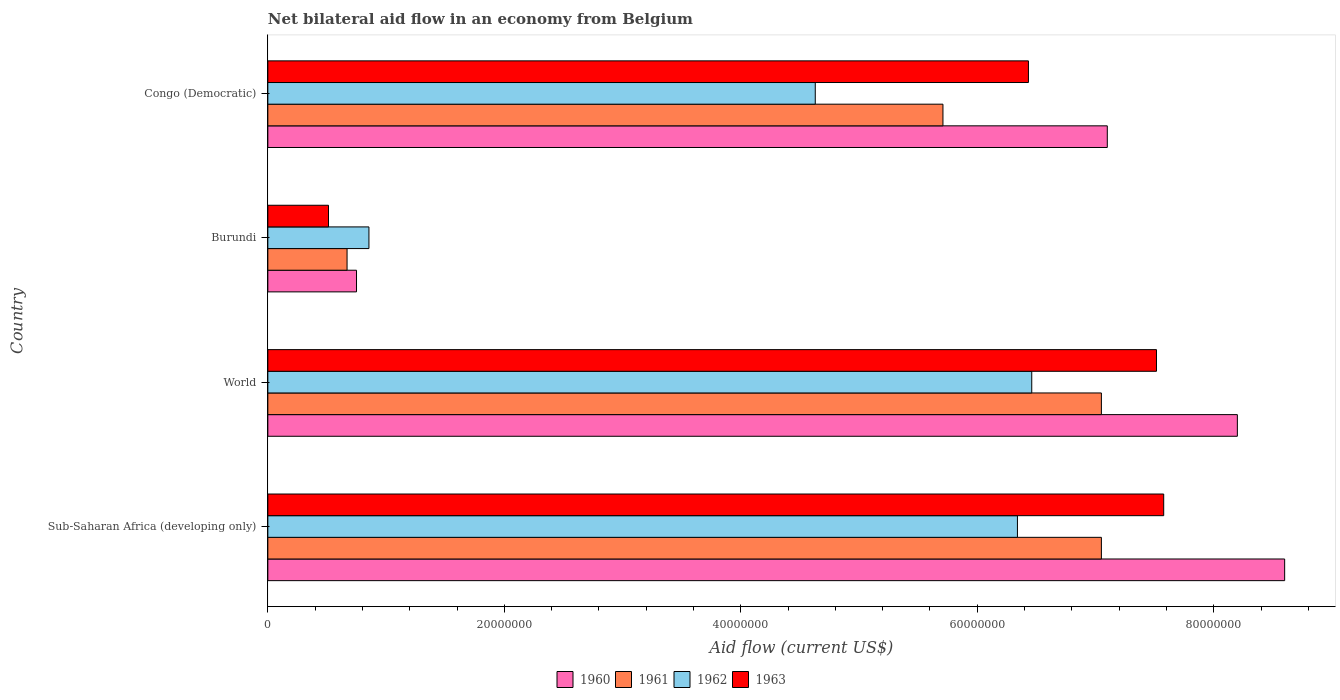How many different coloured bars are there?
Give a very brief answer. 4. How many groups of bars are there?
Provide a short and direct response. 4. Are the number of bars per tick equal to the number of legend labels?
Your answer should be compact. Yes. What is the label of the 4th group of bars from the top?
Offer a very short reply. Sub-Saharan Africa (developing only). In how many cases, is the number of bars for a given country not equal to the number of legend labels?
Give a very brief answer. 0. What is the net bilateral aid flow in 1960 in Sub-Saharan Africa (developing only)?
Keep it short and to the point. 8.60e+07. Across all countries, what is the maximum net bilateral aid flow in 1960?
Offer a terse response. 8.60e+07. Across all countries, what is the minimum net bilateral aid flow in 1962?
Offer a terse response. 8.55e+06. In which country was the net bilateral aid flow in 1960 maximum?
Give a very brief answer. Sub-Saharan Africa (developing only). In which country was the net bilateral aid flow in 1962 minimum?
Make the answer very short. Burundi. What is the total net bilateral aid flow in 1962 in the graph?
Ensure brevity in your answer.  1.83e+08. What is the difference between the net bilateral aid flow in 1963 in Burundi and that in Sub-Saharan Africa (developing only)?
Your answer should be very brief. -7.06e+07. What is the difference between the net bilateral aid flow in 1963 in Burundi and the net bilateral aid flow in 1962 in World?
Offer a very short reply. -5.95e+07. What is the average net bilateral aid flow in 1960 per country?
Keep it short and to the point. 6.16e+07. What is the difference between the net bilateral aid flow in 1961 and net bilateral aid flow in 1960 in Burundi?
Give a very brief answer. -8.00e+05. In how many countries, is the net bilateral aid flow in 1962 greater than 12000000 US$?
Your response must be concise. 3. What is the ratio of the net bilateral aid flow in 1960 in Burundi to that in Sub-Saharan Africa (developing only)?
Your answer should be very brief. 0.09. Is the net bilateral aid flow in 1962 in Burundi less than that in Congo (Democratic)?
Ensure brevity in your answer.  Yes. What is the difference between the highest and the second highest net bilateral aid flow in 1960?
Make the answer very short. 4.00e+06. What is the difference between the highest and the lowest net bilateral aid flow in 1960?
Your response must be concise. 7.85e+07. In how many countries, is the net bilateral aid flow in 1961 greater than the average net bilateral aid flow in 1961 taken over all countries?
Provide a short and direct response. 3. Is it the case that in every country, the sum of the net bilateral aid flow in 1960 and net bilateral aid flow in 1963 is greater than the sum of net bilateral aid flow in 1962 and net bilateral aid flow in 1961?
Provide a short and direct response. No. Is it the case that in every country, the sum of the net bilateral aid flow in 1963 and net bilateral aid flow in 1961 is greater than the net bilateral aid flow in 1960?
Offer a very short reply. Yes. How many bars are there?
Provide a succinct answer. 16. Are all the bars in the graph horizontal?
Provide a short and direct response. Yes. What is the difference between two consecutive major ticks on the X-axis?
Give a very brief answer. 2.00e+07. Are the values on the major ticks of X-axis written in scientific E-notation?
Your response must be concise. No. Does the graph contain any zero values?
Offer a very short reply. No. Does the graph contain grids?
Offer a terse response. No. How many legend labels are there?
Offer a terse response. 4. How are the legend labels stacked?
Offer a terse response. Horizontal. What is the title of the graph?
Keep it short and to the point. Net bilateral aid flow in an economy from Belgium. Does "2014" appear as one of the legend labels in the graph?
Your response must be concise. No. What is the Aid flow (current US$) of 1960 in Sub-Saharan Africa (developing only)?
Your response must be concise. 8.60e+07. What is the Aid flow (current US$) of 1961 in Sub-Saharan Africa (developing only)?
Provide a short and direct response. 7.05e+07. What is the Aid flow (current US$) in 1962 in Sub-Saharan Africa (developing only)?
Provide a short and direct response. 6.34e+07. What is the Aid flow (current US$) in 1963 in Sub-Saharan Africa (developing only)?
Your response must be concise. 7.58e+07. What is the Aid flow (current US$) in 1960 in World?
Give a very brief answer. 8.20e+07. What is the Aid flow (current US$) in 1961 in World?
Offer a very short reply. 7.05e+07. What is the Aid flow (current US$) in 1962 in World?
Offer a very short reply. 6.46e+07. What is the Aid flow (current US$) in 1963 in World?
Provide a succinct answer. 7.52e+07. What is the Aid flow (current US$) of 1960 in Burundi?
Provide a short and direct response. 7.50e+06. What is the Aid flow (current US$) in 1961 in Burundi?
Provide a succinct answer. 6.70e+06. What is the Aid flow (current US$) of 1962 in Burundi?
Ensure brevity in your answer.  8.55e+06. What is the Aid flow (current US$) in 1963 in Burundi?
Give a very brief answer. 5.13e+06. What is the Aid flow (current US$) of 1960 in Congo (Democratic)?
Offer a terse response. 7.10e+07. What is the Aid flow (current US$) of 1961 in Congo (Democratic)?
Offer a very short reply. 5.71e+07. What is the Aid flow (current US$) of 1962 in Congo (Democratic)?
Your answer should be compact. 4.63e+07. What is the Aid flow (current US$) in 1963 in Congo (Democratic)?
Ensure brevity in your answer.  6.43e+07. Across all countries, what is the maximum Aid flow (current US$) of 1960?
Your answer should be compact. 8.60e+07. Across all countries, what is the maximum Aid flow (current US$) of 1961?
Make the answer very short. 7.05e+07. Across all countries, what is the maximum Aid flow (current US$) in 1962?
Your response must be concise. 6.46e+07. Across all countries, what is the maximum Aid flow (current US$) in 1963?
Provide a short and direct response. 7.58e+07. Across all countries, what is the minimum Aid flow (current US$) of 1960?
Ensure brevity in your answer.  7.50e+06. Across all countries, what is the minimum Aid flow (current US$) in 1961?
Offer a very short reply. 6.70e+06. Across all countries, what is the minimum Aid flow (current US$) in 1962?
Offer a very short reply. 8.55e+06. Across all countries, what is the minimum Aid flow (current US$) of 1963?
Offer a very short reply. 5.13e+06. What is the total Aid flow (current US$) in 1960 in the graph?
Offer a very short reply. 2.46e+08. What is the total Aid flow (current US$) in 1961 in the graph?
Ensure brevity in your answer.  2.05e+08. What is the total Aid flow (current US$) of 1962 in the graph?
Your response must be concise. 1.83e+08. What is the total Aid flow (current US$) in 1963 in the graph?
Make the answer very short. 2.20e+08. What is the difference between the Aid flow (current US$) in 1960 in Sub-Saharan Africa (developing only) and that in World?
Make the answer very short. 4.00e+06. What is the difference between the Aid flow (current US$) of 1961 in Sub-Saharan Africa (developing only) and that in World?
Your response must be concise. 0. What is the difference between the Aid flow (current US$) of 1962 in Sub-Saharan Africa (developing only) and that in World?
Your answer should be very brief. -1.21e+06. What is the difference between the Aid flow (current US$) in 1963 in Sub-Saharan Africa (developing only) and that in World?
Make the answer very short. 6.10e+05. What is the difference between the Aid flow (current US$) in 1960 in Sub-Saharan Africa (developing only) and that in Burundi?
Provide a short and direct response. 7.85e+07. What is the difference between the Aid flow (current US$) in 1961 in Sub-Saharan Africa (developing only) and that in Burundi?
Ensure brevity in your answer.  6.38e+07. What is the difference between the Aid flow (current US$) of 1962 in Sub-Saharan Africa (developing only) and that in Burundi?
Keep it short and to the point. 5.48e+07. What is the difference between the Aid flow (current US$) in 1963 in Sub-Saharan Africa (developing only) and that in Burundi?
Make the answer very short. 7.06e+07. What is the difference between the Aid flow (current US$) in 1960 in Sub-Saharan Africa (developing only) and that in Congo (Democratic)?
Provide a short and direct response. 1.50e+07. What is the difference between the Aid flow (current US$) of 1961 in Sub-Saharan Africa (developing only) and that in Congo (Democratic)?
Offer a very short reply. 1.34e+07. What is the difference between the Aid flow (current US$) of 1962 in Sub-Saharan Africa (developing only) and that in Congo (Democratic)?
Give a very brief answer. 1.71e+07. What is the difference between the Aid flow (current US$) in 1963 in Sub-Saharan Africa (developing only) and that in Congo (Democratic)?
Ensure brevity in your answer.  1.14e+07. What is the difference between the Aid flow (current US$) of 1960 in World and that in Burundi?
Give a very brief answer. 7.45e+07. What is the difference between the Aid flow (current US$) of 1961 in World and that in Burundi?
Ensure brevity in your answer.  6.38e+07. What is the difference between the Aid flow (current US$) in 1962 in World and that in Burundi?
Provide a short and direct response. 5.61e+07. What is the difference between the Aid flow (current US$) of 1963 in World and that in Burundi?
Provide a succinct answer. 7.00e+07. What is the difference between the Aid flow (current US$) in 1960 in World and that in Congo (Democratic)?
Ensure brevity in your answer.  1.10e+07. What is the difference between the Aid flow (current US$) in 1961 in World and that in Congo (Democratic)?
Provide a short and direct response. 1.34e+07. What is the difference between the Aid flow (current US$) in 1962 in World and that in Congo (Democratic)?
Offer a terse response. 1.83e+07. What is the difference between the Aid flow (current US$) in 1963 in World and that in Congo (Democratic)?
Your response must be concise. 1.08e+07. What is the difference between the Aid flow (current US$) of 1960 in Burundi and that in Congo (Democratic)?
Provide a short and direct response. -6.35e+07. What is the difference between the Aid flow (current US$) in 1961 in Burundi and that in Congo (Democratic)?
Ensure brevity in your answer.  -5.04e+07. What is the difference between the Aid flow (current US$) in 1962 in Burundi and that in Congo (Democratic)?
Ensure brevity in your answer.  -3.78e+07. What is the difference between the Aid flow (current US$) of 1963 in Burundi and that in Congo (Democratic)?
Provide a succinct answer. -5.92e+07. What is the difference between the Aid flow (current US$) in 1960 in Sub-Saharan Africa (developing only) and the Aid flow (current US$) in 1961 in World?
Offer a very short reply. 1.55e+07. What is the difference between the Aid flow (current US$) of 1960 in Sub-Saharan Africa (developing only) and the Aid flow (current US$) of 1962 in World?
Provide a short and direct response. 2.14e+07. What is the difference between the Aid flow (current US$) of 1960 in Sub-Saharan Africa (developing only) and the Aid flow (current US$) of 1963 in World?
Your answer should be very brief. 1.08e+07. What is the difference between the Aid flow (current US$) in 1961 in Sub-Saharan Africa (developing only) and the Aid flow (current US$) in 1962 in World?
Your answer should be very brief. 5.89e+06. What is the difference between the Aid flow (current US$) in 1961 in Sub-Saharan Africa (developing only) and the Aid flow (current US$) in 1963 in World?
Make the answer very short. -4.66e+06. What is the difference between the Aid flow (current US$) in 1962 in Sub-Saharan Africa (developing only) and the Aid flow (current US$) in 1963 in World?
Keep it short and to the point. -1.18e+07. What is the difference between the Aid flow (current US$) in 1960 in Sub-Saharan Africa (developing only) and the Aid flow (current US$) in 1961 in Burundi?
Give a very brief answer. 7.93e+07. What is the difference between the Aid flow (current US$) in 1960 in Sub-Saharan Africa (developing only) and the Aid flow (current US$) in 1962 in Burundi?
Your answer should be compact. 7.74e+07. What is the difference between the Aid flow (current US$) in 1960 in Sub-Saharan Africa (developing only) and the Aid flow (current US$) in 1963 in Burundi?
Offer a very short reply. 8.09e+07. What is the difference between the Aid flow (current US$) of 1961 in Sub-Saharan Africa (developing only) and the Aid flow (current US$) of 1962 in Burundi?
Provide a succinct answer. 6.20e+07. What is the difference between the Aid flow (current US$) of 1961 in Sub-Saharan Africa (developing only) and the Aid flow (current US$) of 1963 in Burundi?
Ensure brevity in your answer.  6.54e+07. What is the difference between the Aid flow (current US$) in 1962 in Sub-Saharan Africa (developing only) and the Aid flow (current US$) in 1963 in Burundi?
Provide a succinct answer. 5.83e+07. What is the difference between the Aid flow (current US$) in 1960 in Sub-Saharan Africa (developing only) and the Aid flow (current US$) in 1961 in Congo (Democratic)?
Ensure brevity in your answer.  2.89e+07. What is the difference between the Aid flow (current US$) in 1960 in Sub-Saharan Africa (developing only) and the Aid flow (current US$) in 1962 in Congo (Democratic)?
Your response must be concise. 3.97e+07. What is the difference between the Aid flow (current US$) of 1960 in Sub-Saharan Africa (developing only) and the Aid flow (current US$) of 1963 in Congo (Democratic)?
Offer a very short reply. 2.17e+07. What is the difference between the Aid flow (current US$) in 1961 in Sub-Saharan Africa (developing only) and the Aid flow (current US$) in 1962 in Congo (Democratic)?
Keep it short and to the point. 2.42e+07. What is the difference between the Aid flow (current US$) of 1961 in Sub-Saharan Africa (developing only) and the Aid flow (current US$) of 1963 in Congo (Democratic)?
Ensure brevity in your answer.  6.17e+06. What is the difference between the Aid flow (current US$) in 1962 in Sub-Saharan Africa (developing only) and the Aid flow (current US$) in 1963 in Congo (Democratic)?
Your answer should be compact. -9.30e+05. What is the difference between the Aid flow (current US$) in 1960 in World and the Aid flow (current US$) in 1961 in Burundi?
Your answer should be very brief. 7.53e+07. What is the difference between the Aid flow (current US$) in 1960 in World and the Aid flow (current US$) in 1962 in Burundi?
Your answer should be very brief. 7.34e+07. What is the difference between the Aid flow (current US$) of 1960 in World and the Aid flow (current US$) of 1963 in Burundi?
Provide a short and direct response. 7.69e+07. What is the difference between the Aid flow (current US$) of 1961 in World and the Aid flow (current US$) of 1962 in Burundi?
Your answer should be compact. 6.20e+07. What is the difference between the Aid flow (current US$) in 1961 in World and the Aid flow (current US$) in 1963 in Burundi?
Your answer should be compact. 6.54e+07. What is the difference between the Aid flow (current US$) of 1962 in World and the Aid flow (current US$) of 1963 in Burundi?
Your answer should be compact. 5.95e+07. What is the difference between the Aid flow (current US$) in 1960 in World and the Aid flow (current US$) in 1961 in Congo (Democratic)?
Offer a very short reply. 2.49e+07. What is the difference between the Aid flow (current US$) in 1960 in World and the Aid flow (current US$) in 1962 in Congo (Democratic)?
Ensure brevity in your answer.  3.57e+07. What is the difference between the Aid flow (current US$) in 1960 in World and the Aid flow (current US$) in 1963 in Congo (Democratic)?
Give a very brief answer. 1.77e+07. What is the difference between the Aid flow (current US$) of 1961 in World and the Aid flow (current US$) of 1962 in Congo (Democratic)?
Provide a short and direct response. 2.42e+07. What is the difference between the Aid flow (current US$) in 1961 in World and the Aid flow (current US$) in 1963 in Congo (Democratic)?
Ensure brevity in your answer.  6.17e+06. What is the difference between the Aid flow (current US$) in 1960 in Burundi and the Aid flow (current US$) in 1961 in Congo (Democratic)?
Keep it short and to the point. -4.96e+07. What is the difference between the Aid flow (current US$) of 1960 in Burundi and the Aid flow (current US$) of 1962 in Congo (Democratic)?
Make the answer very short. -3.88e+07. What is the difference between the Aid flow (current US$) of 1960 in Burundi and the Aid flow (current US$) of 1963 in Congo (Democratic)?
Your answer should be very brief. -5.68e+07. What is the difference between the Aid flow (current US$) in 1961 in Burundi and the Aid flow (current US$) in 1962 in Congo (Democratic)?
Keep it short and to the point. -3.96e+07. What is the difference between the Aid flow (current US$) in 1961 in Burundi and the Aid flow (current US$) in 1963 in Congo (Democratic)?
Your answer should be very brief. -5.76e+07. What is the difference between the Aid flow (current US$) in 1962 in Burundi and the Aid flow (current US$) in 1963 in Congo (Democratic)?
Offer a very short reply. -5.58e+07. What is the average Aid flow (current US$) in 1960 per country?
Provide a succinct answer. 6.16e+07. What is the average Aid flow (current US$) of 1961 per country?
Offer a very short reply. 5.12e+07. What is the average Aid flow (current US$) of 1962 per country?
Offer a terse response. 4.57e+07. What is the average Aid flow (current US$) in 1963 per country?
Your answer should be very brief. 5.51e+07. What is the difference between the Aid flow (current US$) in 1960 and Aid flow (current US$) in 1961 in Sub-Saharan Africa (developing only)?
Give a very brief answer. 1.55e+07. What is the difference between the Aid flow (current US$) in 1960 and Aid flow (current US$) in 1962 in Sub-Saharan Africa (developing only)?
Keep it short and to the point. 2.26e+07. What is the difference between the Aid flow (current US$) in 1960 and Aid flow (current US$) in 1963 in Sub-Saharan Africa (developing only)?
Your answer should be very brief. 1.02e+07. What is the difference between the Aid flow (current US$) of 1961 and Aid flow (current US$) of 1962 in Sub-Saharan Africa (developing only)?
Ensure brevity in your answer.  7.10e+06. What is the difference between the Aid flow (current US$) in 1961 and Aid flow (current US$) in 1963 in Sub-Saharan Africa (developing only)?
Your answer should be very brief. -5.27e+06. What is the difference between the Aid flow (current US$) of 1962 and Aid flow (current US$) of 1963 in Sub-Saharan Africa (developing only)?
Ensure brevity in your answer.  -1.24e+07. What is the difference between the Aid flow (current US$) in 1960 and Aid flow (current US$) in 1961 in World?
Keep it short and to the point. 1.15e+07. What is the difference between the Aid flow (current US$) in 1960 and Aid flow (current US$) in 1962 in World?
Offer a terse response. 1.74e+07. What is the difference between the Aid flow (current US$) of 1960 and Aid flow (current US$) of 1963 in World?
Your answer should be very brief. 6.84e+06. What is the difference between the Aid flow (current US$) in 1961 and Aid flow (current US$) in 1962 in World?
Offer a very short reply. 5.89e+06. What is the difference between the Aid flow (current US$) in 1961 and Aid flow (current US$) in 1963 in World?
Offer a terse response. -4.66e+06. What is the difference between the Aid flow (current US$) of 1962 and Aid flow (current US$) of 1963 in World?
Offer a terse response. -1.06e+07. What is the difference between the Aid flow (current US$) of 1960 and Aid flow (current US$) of 1962 in Burundi?
Your answer should be very brief. -1.05e+06. What is the difference between the Aid flow (current US$) in 1960 and Aid flow (current US$) in 1963 in Burundi?
Give a very brief answer. 2.37e+06. What is the difference between the Aid flow (current US$) in 1961 and Aid flow (current US$) in 1962 in Burundi?
Your answer should be compact. -1.85e+06. What is the difference between the Aid flow (current US$) of 1961 and Aid flow (current US$) of 1963 in Burundi?
Keep it short and to the point. 1.57e+06. What is the difference between the Aid flow (current US$) of 1962 and Aid flow (current US$) of 1963 in Burundi?
Provide a succinct answer. 3.42e+06. What is the difference between the Aid flow (current US$) of 1960 and Aid flow (current US$) of 1961 in Congo (Democratic)?
Your response must be concise. 1.39e+07. What is the difference between the Aid flow (current US$) of 1960 and Aid flow (current US$) of 1962 in Congo (Democratic)?
Offer a terse response. 2.47e+07. What is the difference between the Aid flow (current US$) of 1960 and Aid flow (current US$) of 1963 in Congo (Democratic)?
Provide a short and direct response. 6.67e+06. What is the difference between the Aid flow (current US$) of 1961 and Aid flow (current US$) of 1962 in Congo (Democratic)?
Your answer should be very brief. 1.08e+07. What is the difference between the Aid flow (current US$) in 1961 and Aid flow (current US$) in 1963 in Congo (Democratic)?
Your response must be concise. -7.23e+06. What is the difference between the Aid flow (current US$) of 1962 and Aid flow (current US$) of 1963 in Congo (Democratic)?
Offer a terse response. -1.80e+07. What is the ratio of the Aid flow (current US$) of 1960 in Sub-Saharan Africa (developing only) to that in World?
Provide a succinct answer. 1.05. What is the ratio of the Aid flow (current US$) in 1961 in Sub-Saharan Africa (developing only) to that in World?
Provide a succinct answer. 1. What is the ratio of the Aid flow (current US$) of 1962 in Sub-Saharan Africa (developing only) to that in World?
Keep it short and to the point. 0.98. What is the ratio of the Aid flow (current US$) of 1963 in Sub-Saharan Africa (developing only) to that in World?
Provide a succinct answer. 1.01. What is the ratio of the Aid flow (current US$) in 1960 in Sub-Saharan Africa (developing only) to that in Burundi?
Offer a very short reply. 11.47. What is the ratio of the Aid flow (current US$) in 1961 in Sub-Saharan Africa (developing only) to that in Burundi?
Your answer should be compact. 10.52. What is the ratio of the Aid flow (current US$) of 1962 in Sub-Saharan Africa (developing only) to that in Burundi?
Offer a very short reply. 7.42. What is the ratio of the Aid flow (current US$) in 1963 in Sub-Saharan Africa (developing only) to that in Burundi?
Provide a succinct answer. 14.77. What is the ratio of the Aid flow (current US$) in 1960 in Sub-Saharan Africa (developing only) to that in Congo (Democratic)?
Ensure brevity in your answer.  1.21. What is the ratio of the Aid flow (current US$) in 1961 in Sub-Saharan Africa (developing only) to that in Congo (Democratic)?
Your answer should be compact. 1.23. What is the ratio of the Aid flow (current US$) of 1962 in Sub-Saharan Africa (developing only) to that in Congo (Democratic)?
Your response must be concise. 1.37. What is the ratio of the Aid flow (current US$) of 1963 in Sub-Saharan Africa (developing only) to that in Congo (Democratic)?
Your answer should be compact. 1.18. What is the ratio of the Aid flow (current US$) of 1960 in World to that in Burundi?
Offer a very short reply. 10.93. What is the ratio of the Aid flow (current US$) in 1961 in World to that in Burundi?
Your answer should be very brief. 10.52. What is the ratio of the Aid flow (current US$) of 1962 in World to that in Burundi?
Give a very brief answer. 7.56. What is the ratio of the Aid flow (current US$) in 1963 in World to that in Burundi?
Your answer should be compact. 14.65. What is the ratio of the Aid flow (current US$) of 1960 in World to that in Congo (Democratic)?
Your answer should be very brief. 1.15. What is the ratio of the Aid flow (current US$) of 1961 in World to that in Congo (Democratic)?
Provide a short and direct response. 1.23. What is the ratio of the Aid flow (current US$) of 1962 in World to that in Congo (Democratic)?
Ensure brevity in your answer.  1.4. What is the ratio of the Aid flow (current US$) in 1963 in World to that in Congo (Democratic)?
Provide a short and direct response. 1.17. What is the ratio of the Aid flow (current US$) in 1960 in Burundi to that in Congo (Democratic)?
Offer a very short reply. 0.11. What is the ratio of the Aid flow (current US$) in 1961 in Burundi to that in Congo (Democratic)?
Make the answer very short. 0.12. What is the ratio of the Aid flow (current US$) of 1962 in Burundi to that in Congo (Democratic)?
Your answer should be very brief. 0.18. What is the ratio of the Aid flow (current US$) in 1963 in Burundi to that in Congo (Democratic)?
Your answer should be compact. 0.08. What is the difference between the highest and the second highest Aid flow (current US$) of 1960?
Give a very brief answer. 4.00e+06. What is the difference between the highest and the second highest Aid flow (current US$) in 1961?
Your response must be concise. 0. What is the difference between the highest and the second highest Aid flow (current US$) of 1962?
Make the answer very short. 1.21e+06. What is the difference between the highest and the second highest Aid flow (current US$) of 1963?
Ensure brevity in your answer.  6.10e+05. What is the difference between the highest and the lowest Aid flow (current US$) of 1960?
Your response must be concise. 7.85e+07. What is the difference between the highest and the lowest Aid flow (current US$) of 1961?
Your answer should be compact. 6.38e+07. What is the difference between the highest and the lowest Aid flow (current US$) of 1962?
Give a very brief answer. 5.61e+07. What is the difference between the highest and the lowest Aid flow (current US$) in 1963?
Ensure brevity in your answer.  7.06e+07. 